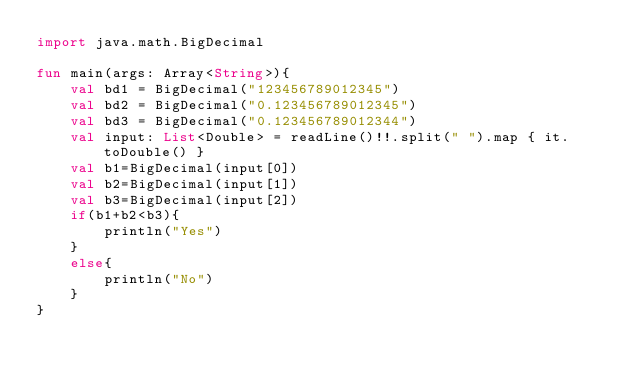<code> <loc_0><loc_0><loc_500><loc_500><_Kotlin_>import java.math.BigDecimal

fun main(args: Array<String>){
    val bd1 = BigDecimal("123456789012345")
    val bd2 = BigDecimal("0.123456789012345")
    val bd3 = BigDecimal("0.123456789012344")
    val input: List<Double> = readLine()!!.split(" ").map { it.toDouble() }
    val b1=BigDecimal(input[0])
    val b2=BigDecimal(input[1])
    val b3=BigDecimal(input[2])
    if(b1+b2<b3){
        println("Yes")
    }
    else{
        println("No")
    }
}</code> 